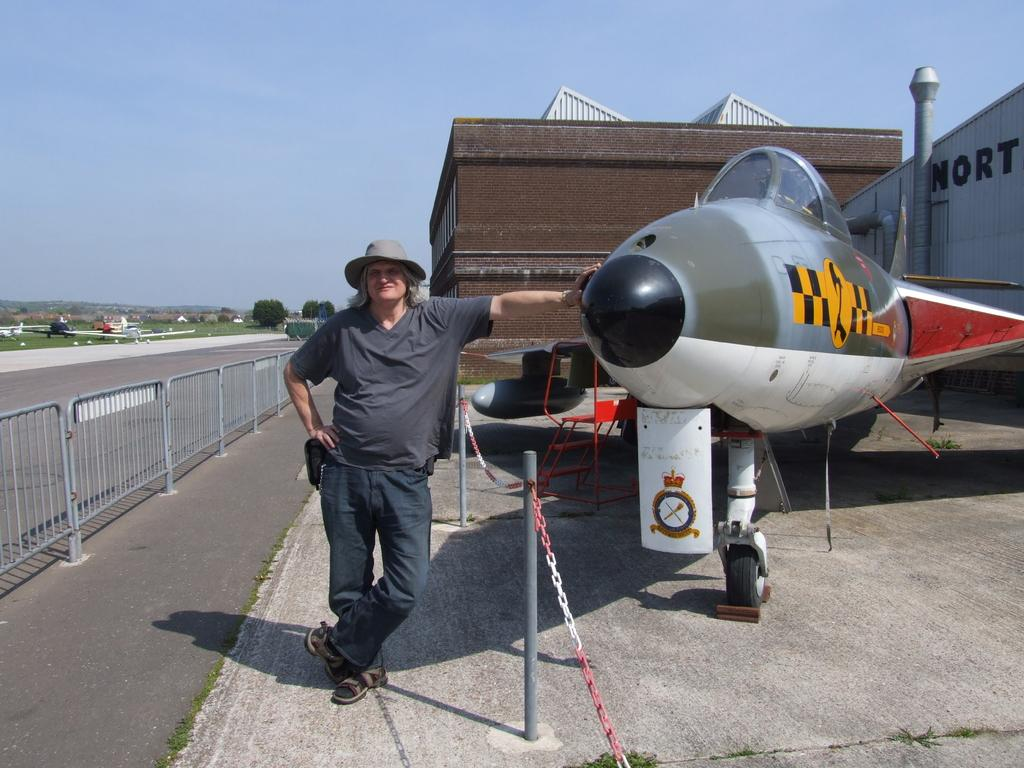<image>
Offer a succinct explanation of the picture presented. A man stands in front of a small jet and a building that has a sign "Nort" something. 